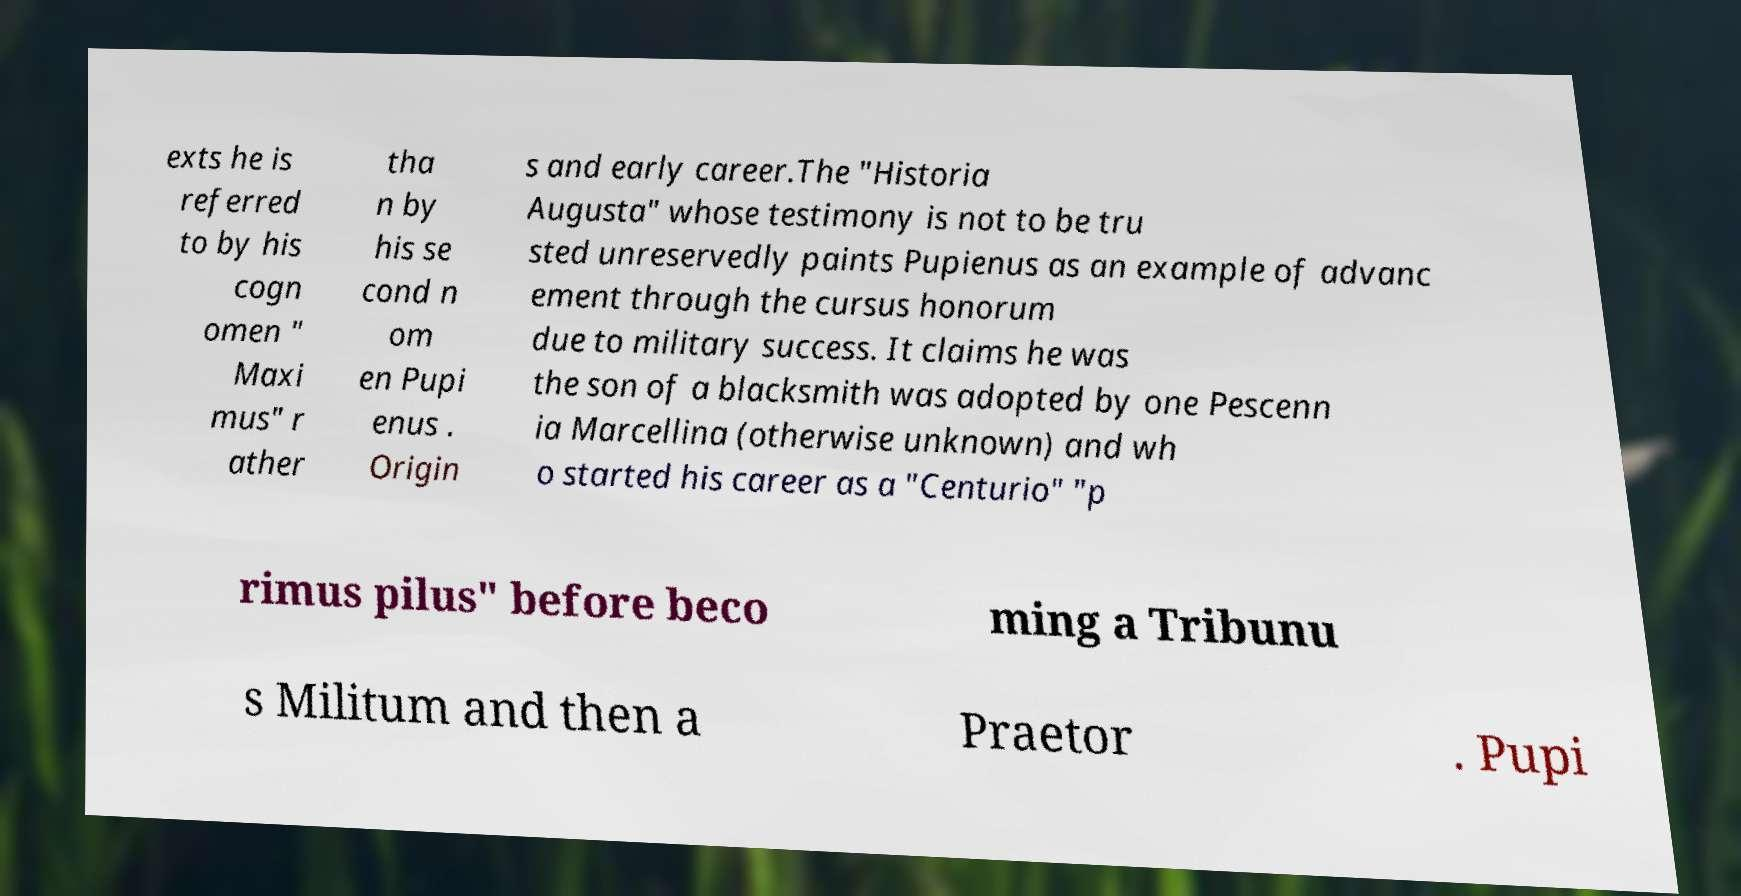Can you read and provide the text displayed in the image?This photo seems to have some interesting text. Can you extract and type it out for me? exts he is referred to by his cogn omen " Maxi mus" r ather tha n by his se cond n om en Pupi enus . Origin s and early career.The "Historia Augusta" whose testimony is not to be tru sted unreservedly paints Pupienus as an example of advanc ement through the cursus honorum due to military success. It claims he was the son of a blacksmith was adopted by one Pescenn ia Marcellina (otherwise unknown) and wh o started his career as a "Centurio" "p rimus pilus" before beco ming a Tribunu s Militum and then a Praetor . Pupi 